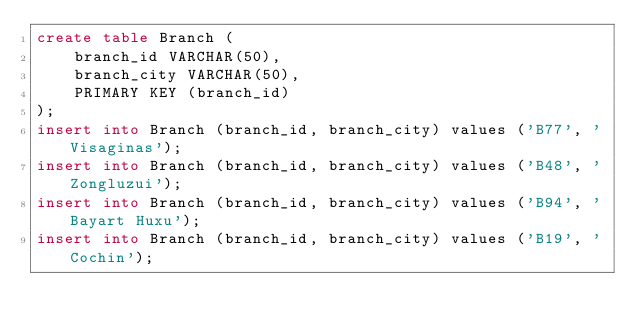Convert code to text. <code><loc_0><loc_0><loc_500><loc_500><_SQL_>create table Branch (
	branch_id VARCHAR(50),
	branch_city VARCHAR(50),
    PRIMARY KEY (branch_id)
);
insert into Branch (branch_id, branch_city) values ('B77', 'Visaginas');
insert into Branch (branch_id, branch_city) values ('B48', 'Zongluzui');
insert into Branch (branch_id, branch_city) values ('B94', 'Bayart Huxu');
insert into Branch (branch_id, branch_city) values ('B19', 'Cochin');
</code> 